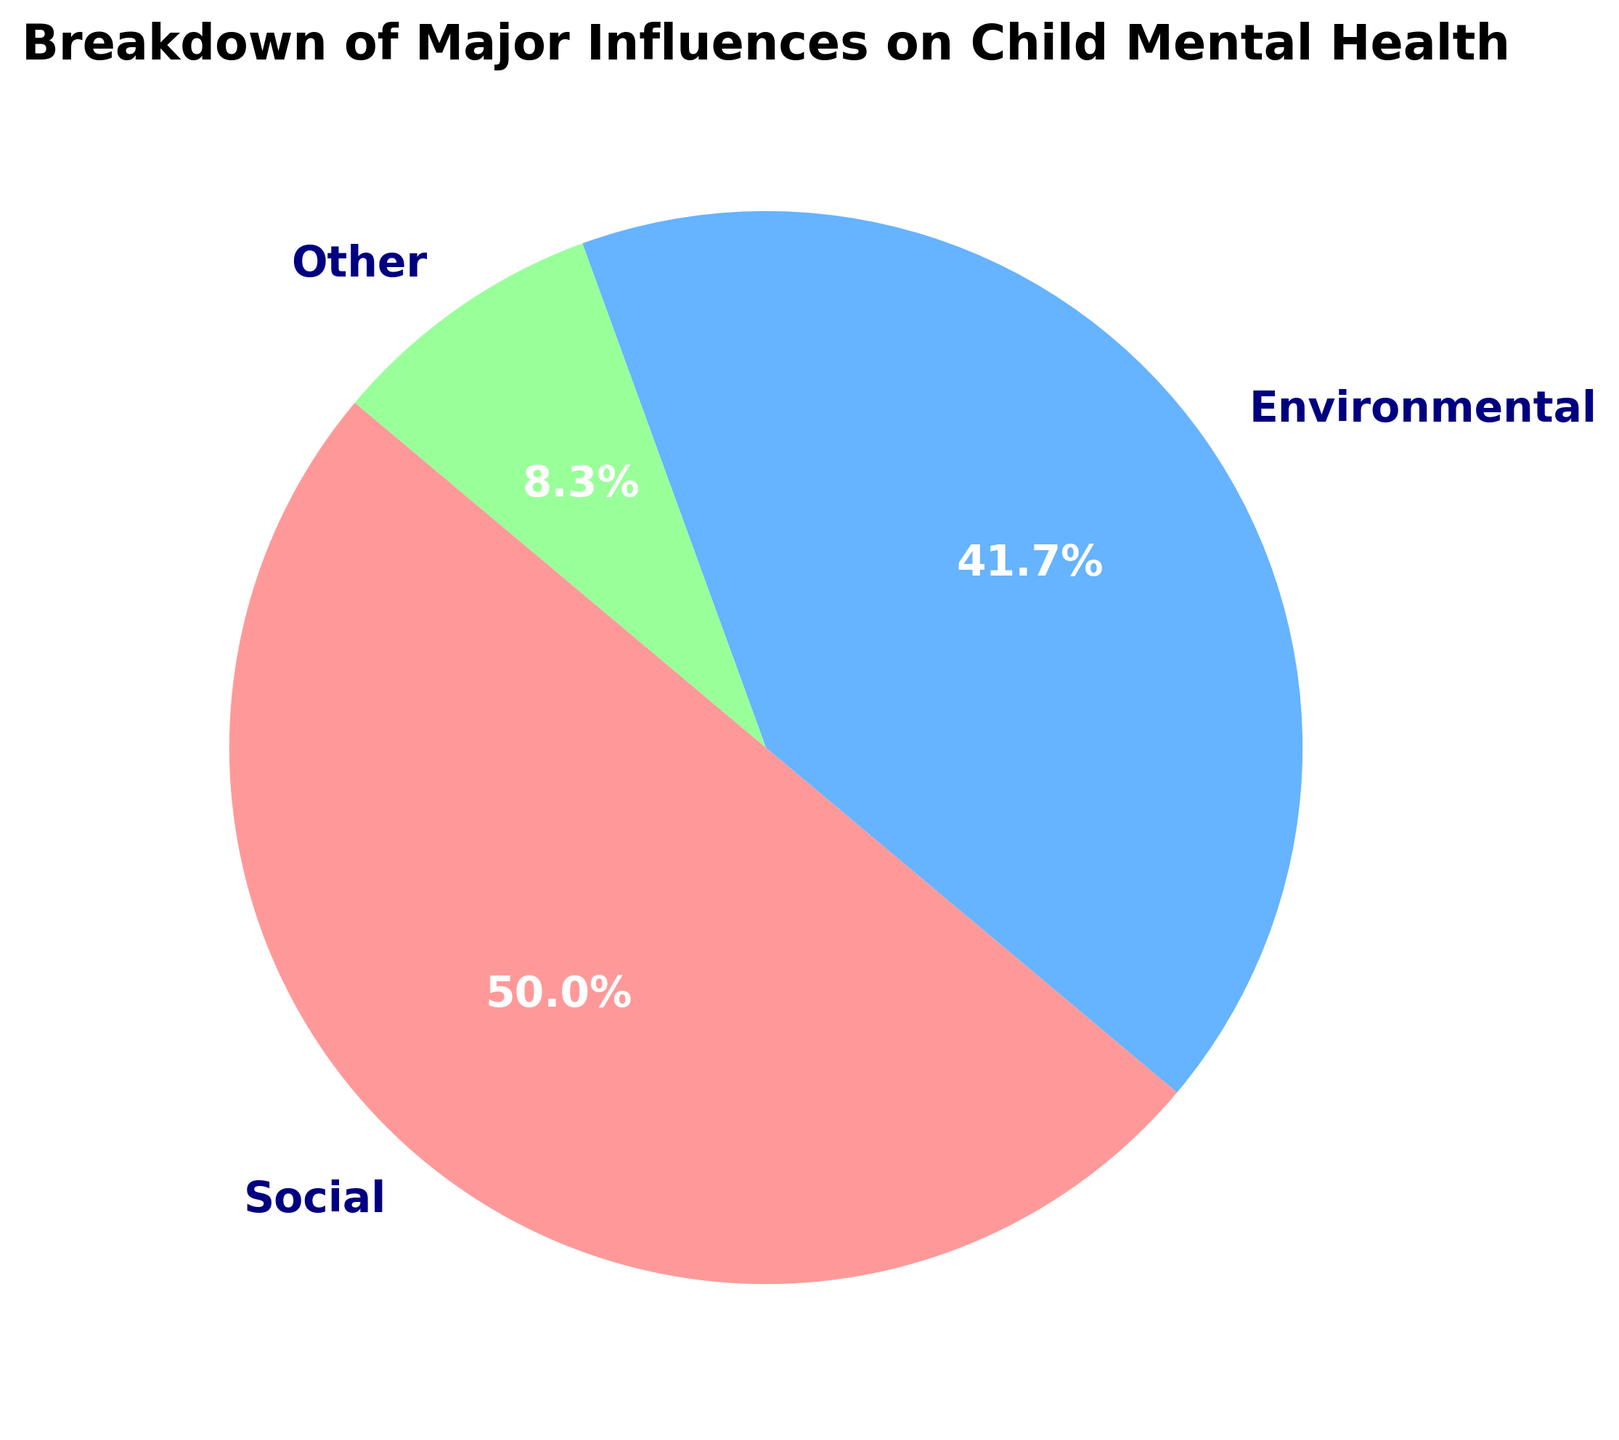What is the largest influence on child mental health according to the pie chart? The pie chart shows that the largest segment is labeled "Genetic" with 40%, indicating that genetic factors are the most significant influence on child mental health.
Answer: Genetic What is the combined percentage of Social and Environmental influences? The pie chart indicates that Social influence is 30% and Environmental influence is 25%. Adding these percentages together gives 30% + 25% = 55%.
Answer: 55% Which category has the smallest influence on child mental health? The smallest segment on the pie chart is labeled "Other" and it has a percentage of 5%.
Answer: Other How much larger is the Genetic influence compared to the Other influence? The pie chart shows Genetic influence as 40% and Other influence as 5%. The difference is calculated as 40% - 5% = 35%.
Answer: 35% What fraction of the total (in percentage) is made up by the Environmental influence? The Environmental influence is labeled as 25% on the pie chart. Since the pie chart represents the total as 100%, Environmental influence makes up 25% of the total.
Answer: 25% If the influence labeled 'Genetic' is represented by a shade of red, what is the color representing the influence labeled 'Environmental'? The pie chart uses a specific color scheme. Based on the description, the Environmental influence is represented by the color green.
Answer: Green What is the difference between the influence of Social factors and Environmental factors? The Social factors occupy 30% of the pie chart while Environmental factors occupy 25%. The difference between them is 30% - 25% = 5%.
Answer: 5% Which two categories together make up just under half of the total influence? The Social and Environmental influences together make up 30% + 25% = 55%. Since 55% is not just under half, checking Genetic and Other: 40% + 5% = 45%, which is just under half.
Answer: Genetic and Other What percentage does the 'Other' category contribute compared to the Social and Environmental combined? The Other category is 5%, and the combined Social and Environmental categories are 30% + 25% = 55%. Calculating the comparison as a percentage: (5 / 55) * 100 ≈ 9.1%.
Answer: 9.1% If Genetic influence was reduced by 10%, how would the percentage distribution across all categories change? Reducing Genetic influence by 10% changes it to 40% - 10% = 30%. Total reduces to 90%. New percentages: Genetic 33.3%, Social 33.3%, Environmental 27.8%, Other 5.6%.
Answer: Genetic 33.3%, Social 33.3%, Environmental 27.8%, Other 5.6% 